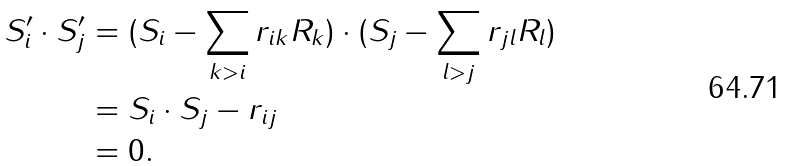Convert formula to latex. <formula><loc_0><loc_0><loc_500><loc_500>S _ { i } ^ { \prime } \cdot S _ { j } ^ { \prime } & = ( S _ { i } - \sum _ { k > i } r _ { i k } R _ { k } ) \cdot ( S _ { j } - \sum _ { l > j } r _ { j l } R _ { l } ) \\ & = S _ { i } \cdot S _ { j } - r _ { i j } \\ & = 0 .</formula> 